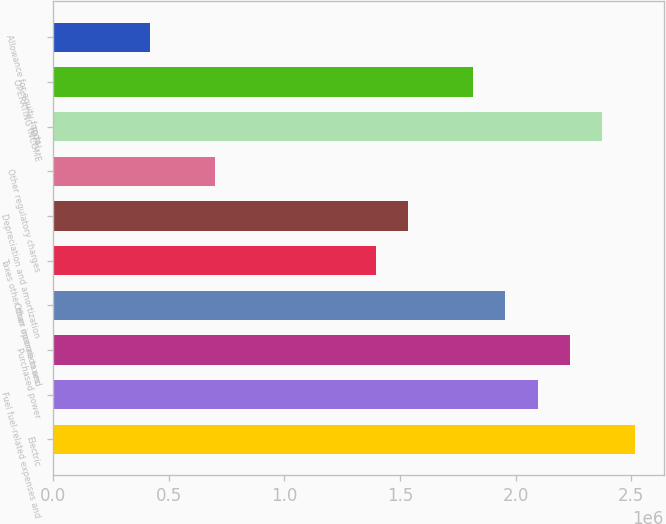Convert chart. <chart><loc_0><loc_0><loc_500><loc_500><bar_chart><fcel>Electric<fcel>Fuel fuel-related expenses and<fcel>Purchased power<fcel>Other operation and<fcel>Taxes other than income taxes<fcel>Depreciation and amortization<fcel>Other regulatory charges<fcel>TOTAL<fcel>OPERATING INCOME<fcel>Allowance for equity funds<nl><fcel>2.51442e+06<fcel>2.09538e+06<fcel>2.23506e+06<fcel>1.9557e+06<fcel>1.39698e+06<fcel>1.53666e+06<fcel>698590<fcel>2.37474e+06<fcel>1.81602e+06<fcel>419232<nl></chart> 